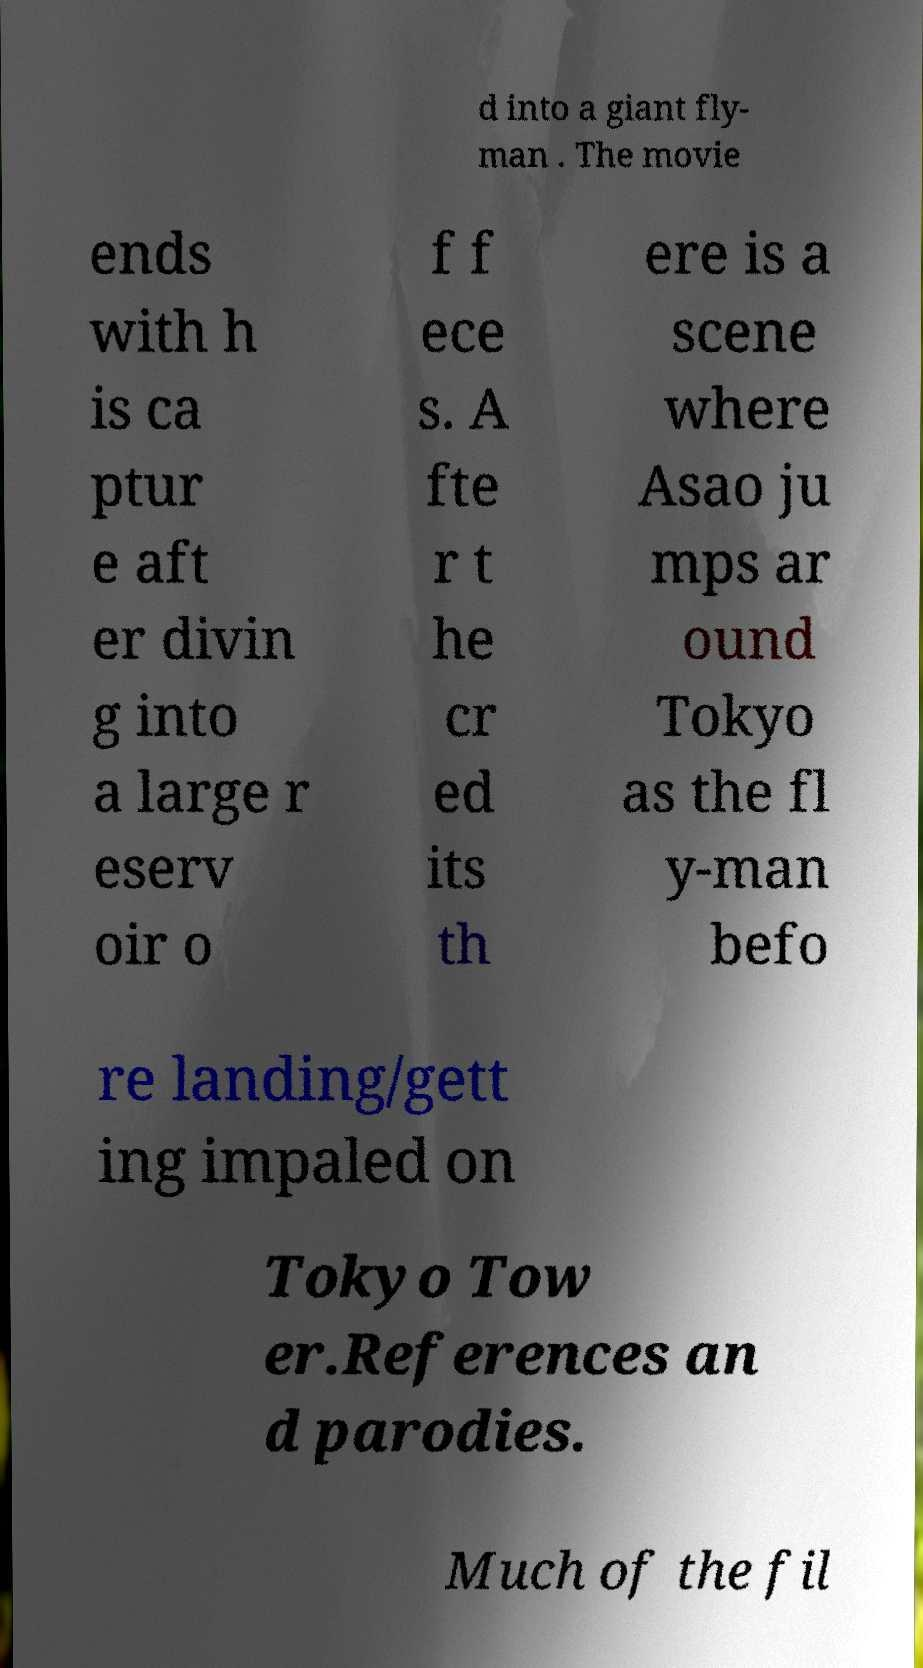Please read and relay the text visible in this image. What does it say? d into a giant fly- man . The movie ends with h is ca ptur e aft er divin g into a large r eserv oir o f f ece s. A fte r t he cr ed its th ere is a scene where Asao ju mps ar ound Tokyo as the fl y-man befo re landing/gett ing impaled on Tokyo Tow er.References an d parodies. Much of the fil 